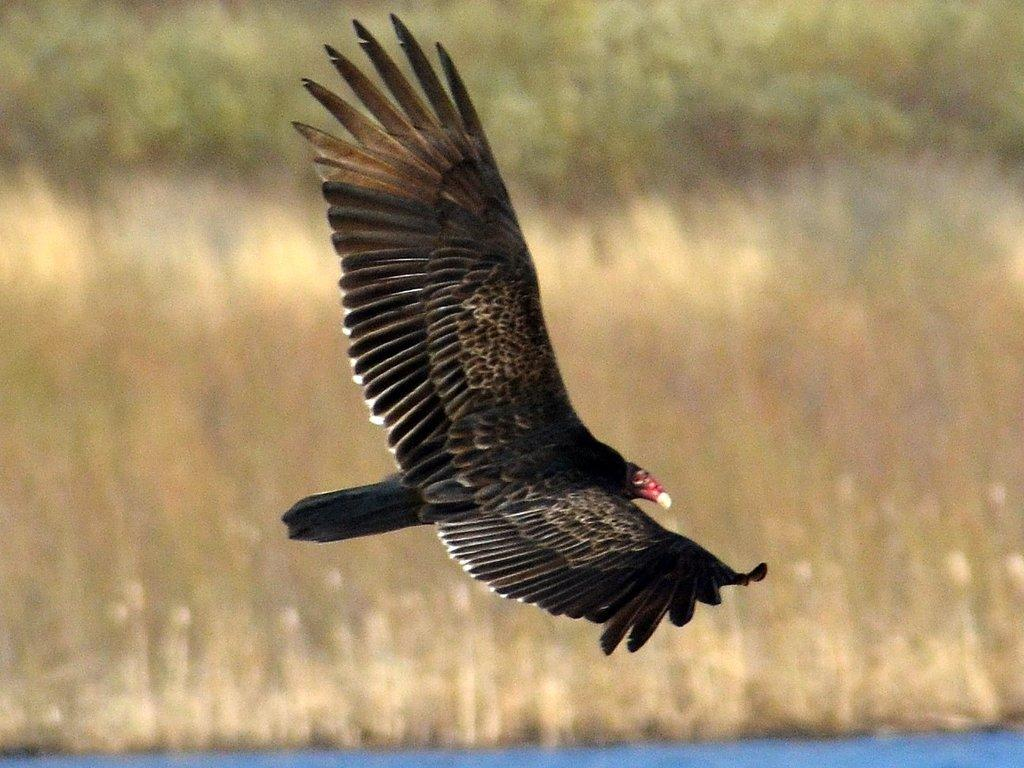What type of animal can be seen in the image? There is a bird in the image. What color is the bird? The bird is black. What is the bird doing in the image? The bird is flying. What color is the bird's beak? The bird has a red color beak. What type of vegetation is visible in the image? There is grass visible in the image. What can be seen in the background of the image? There are trees in the background of the image. How would you describe the background of the image? The background is blurred. What type of experience does the bird's son have in the image? There is no mention of a son or any experience in the image; it simply shows a black bird flying with a red beak. 